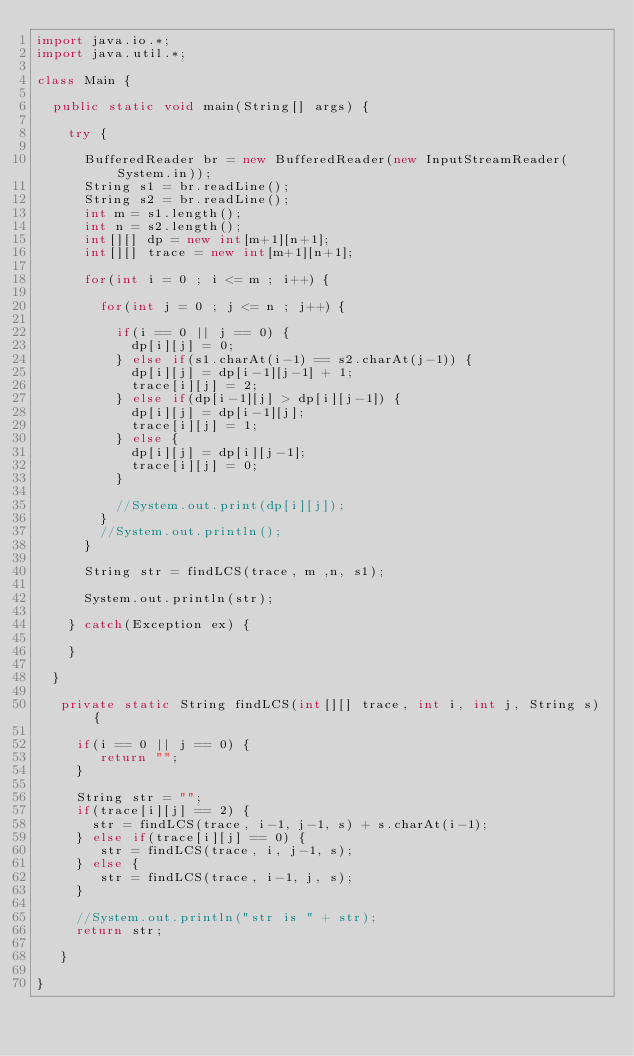<code> <loc_0><loc_0><loc_500><loc_500><_Java_>import java.io.*;
import java.util.*;

class Main {

  public static void main(String[] args) {
  
  	try {
    
      BufferedReader br = new BufferedReader(new InputStreamReader(System.in));
      String s1 = br.readLine();
      String s2 = br.readLine();
      int m = s1.length();
      int n = s2.length();
      int[][] dp = new int[m+1][n+1];
      int[][] trace = new int[m+1][n+1];
      
      for(int i = 0 ; i <= m ; i++) {
      
        for(int j = 0 ; j <= n ; j++) {
        	
          if(i == 0 || j == 0) {
          	dp[i][j] = 0;
          } else if(s1.charAt(i-1) == s2.charAt(j-1)) {
          	dp[i][j] = dp[i-1][j-1] + 1;
            trace[i][j] = 2;
          } else if(dp[i-1][j] > dp[i][j-1]) {
          	dp[i][j] = dp[i-1][j];
            trace[i][j] = 1;
          } else {
          	dp[i][j] = dp[i][j-1];
            trace[i][j] = 0;
          }
          
          //System.out.print(dp[i][j]);
        }
      	//System.out.println();
      }
      
      String str = findLCS(trace, m ,n, s1);              
    
      System.out.println(str);
		                         
    } catch(Exception ex) {
    
    }
  
  }
     
   private static String findLCS(int[][] trace, int i, int j, String s) {
   	
     if(i == 0 || j == 0) {
     	return "";
     }
     
     String str = "";
     if(trace[i][j] == 2) {
       str = findLCS(trace, i-1, j-1, s) + s.charAt(i-1);
     } else if(trace[i][j] == 0) {
     	str = findLCS(trace, i, j-1, s);
     } else {
     	str = findLCS(trace, i-1, j, s);
     }
   	
     //System.out.println("str is " + str);
     return str;
     
   }                                     

}</code> 